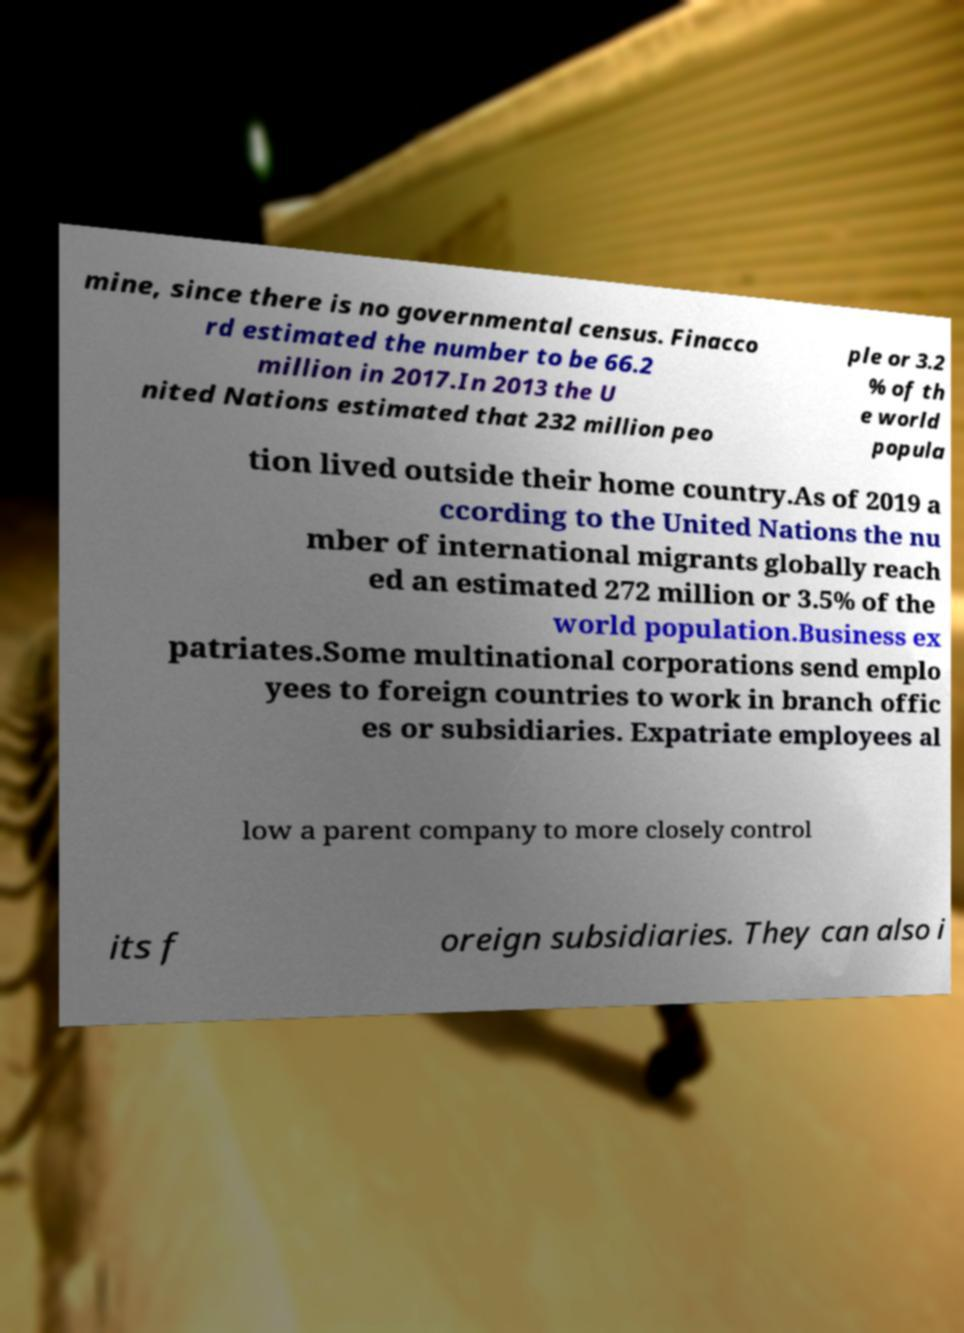Can you accurately transcribe the text from the provided image for me? mine, since there is no governmental census. Finacco rd estimated the number to be 66.2 million in 2017.In 2013 the U nited Nations estimated that 232 million peo ple or 3.2 % of th e world popula tion lived outside their home country.As of 2019 a ccording to the United Nations the nu mber of international migrants globally reach ed an estimated 272 million or 3.5% of the world population.Business ex patriates.Some multinational corporations send emplo yees to foreign countries to work in branch offic es or subsidiaries. Expatriate employees al low a parent company to more closely control its f oreign subsidiaries. They can also i 